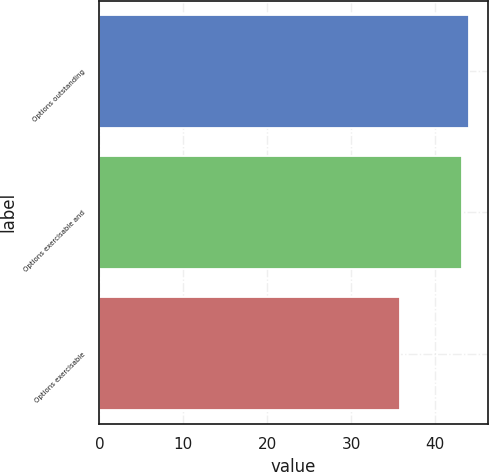Convert chart. <chart><loc_0><loc_0><loc_500><loc_500><bar_chart><fcel>Options outstanding<fcel>Options exercisable and<fcel>Options exercisable<nl><fcel>44.04<fcel>43.24<fcel>35.8<nl></chart> 